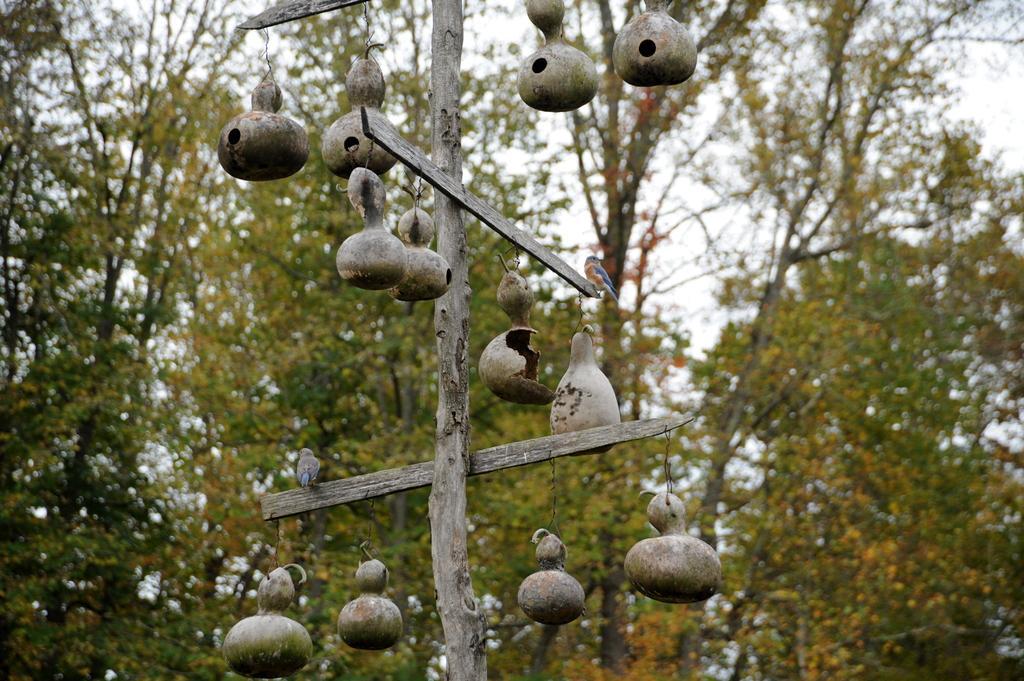Can you describe this image briefly? There are two birds standing. I think these are the nests, which are hanging to the stick. These are the trees with branches and leaves. 